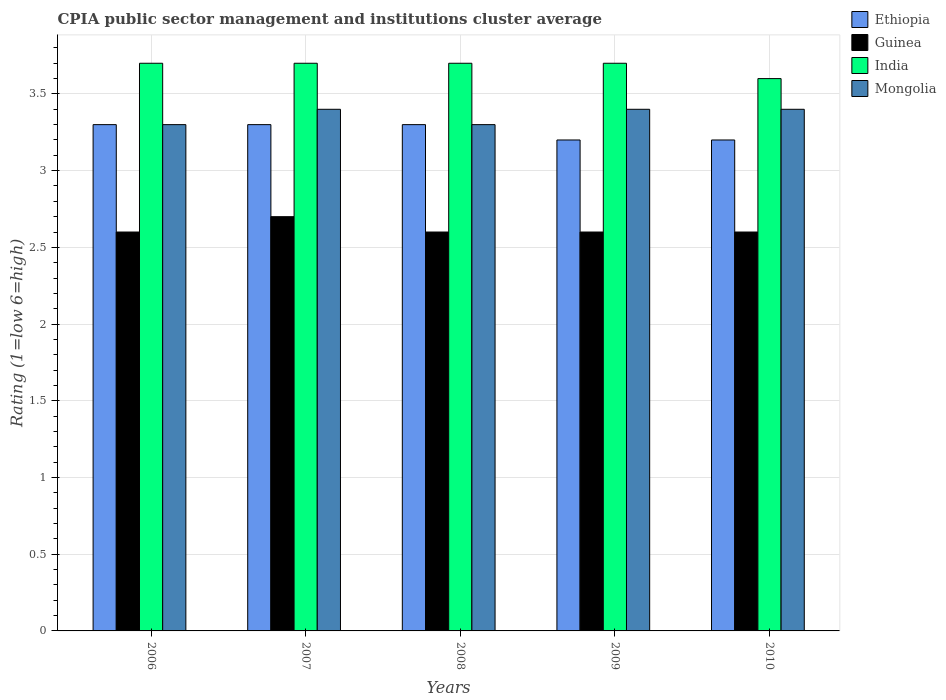How many different coloured bars are there?
Your response must be concise. 4. How many bars are there on the 5th tick from the left?
Your answer should be compact. 4. How many bars are there on the 2nd tick from the right?
Provide a succinct answer. 4. What is the label of the 4th group of bars from the left?
Your answer should be very brief. 2009. What is the CPIA rating in India in 2008?
Provide a succinct answer. 3.7. Across all years, what is the maximum CPIA rating in Ethiopia?
Ensure brevity in your answer.  3.3. Across all years, what is the minimum CPIA rating in Ethiopia?
Provide a short and direct response. 3.2. In which year was the CPIA rating in India maximum?
Offer a terse response. 2006. In which year was the CPIA rating in Guinea minimum?
Provide a short and direct response. 2006. What is the difference between the CPIA rating in Mongolia in 2006 and that in 2010?
Provide a short and direct response. -0.1. What is the difference between the CPIA rating in Guinea in 2010 and the CPIA rating in Mongolia in 2009?
Your answer should be compact. -0.8. What is the average CPIA rating in Ethiopia per year?
Your answer should be very brief. 3.26. In the year 2008, what is the difference between the CPIA rating in India and CPIA rating in Guinea?
Make the answer very short. 1.1. In how many years, is the CPIA rating in Guinea greater than 0.5?
Provide a short and direct response. 5. What is the ratio of the CPIA rating in Ethiopia in 2007 to that in 2008?
Provide a short and direct response. 1. Is the CPIA rating in India in 2007 less than that in 2008?
Keep it short and to the point. No. Is the difference between the CPIA rating in India in 2007 and 2009 greater than the difference between the CPIA rating in Guinea in 2007 and 2009?
Your answer should be compact. No. What is the difference between the highest and the lowest CPIA rating in Ethiopia?
Give a very brief answer. 0.1. Is the sum of the CPIA rating in India in 2006 and 2007 greater than the maximum CPIA rating in Ethiopia across all years?
Provide a succinct answer. Yes. What does the 1st bar from the left in 2010 represents?
Provide a short and direct response. Ethiopia. What does the 1st bar from the right in 2006 represents?
Offer a terse response. Mongolia. Are all the bars in the graph horizontal?
Provide a succinct answer. No. What is the difference between two consecutive major ticks on the Y-axis?
Your answer should be compact. 0.5. Are the values on the major ticks of Y-axis written in scientific E-notation?
Your response must be concise. No. Does the graph contain grids?
Offer a very short reply. Yes. Where does the legend appear in the graph?
Make the answer very short. Top right. How many legend labels are there?
Your answer should be compact. 4. How are the legend labels stacked?
Provide a short and direct response. Vertical. What is the title of the graph?
Ensure brevity in your answer.  CPIA public sector management and institutions cluster average. Does "Euro area" appear as one of the legend labels in the graph?
Provide a succinct answer. No. What is the Rating (1=low 6=high) of Ethiopia in 2006?
Provide a short and direct response. 3.3. What is the Rating (1=low 6=high) of Guinea in 2006?
Make the answer very short. 2.6. What is the Rating (1=low 6=high) of India in 2006?
Your response must be concise. 3.7. What is the Rating (1=low 6=high) in Mongolia in 2006?
Your answer should be very brief. 3.3. What is the Rating (1=low 6=high) in Ethiopia in 2007?
Provide a succinct answer. 3.3. What is the Rating (1=low 6=high) of India in 2008?
Your response must be concise. 3.7. What is the Rating (1=low 6=high) of Guinea in 2009?
Provide a succinct answer. 2.6. What is the Rating (1=low 6=high) in India in 2009?
Your answer should be very brief. 3.7. What is the Rating (1=low 6=high) in Mongolia in 2009?
Your answer should be compact. 3.4. What is the Rating (1=low 6=high) in Guinea in 2010?
Your response must be concise. 2.6. What is the Rating (1=low 6=high) of India in 2010?
Offer a very short reply. 3.6. Across all years, what is the maximum Rating (1=low 6=high) of Ethiopia?
Make the answer very short. 3.3. Across all years, what is the maximum Rating (1=low 6=high) in Guinea?
Ensure brevity in your answer.  2.7. Across all years, what is the minimum Rating (1=low 6=high) in India?
Give a very brief answer. 3.6. Across all years, what is the minimum Rating (1=low 6=high) in Mongolia?
Offer a very short reply. 3.3. What is the total Rating (1=low 6=high) in Ethiopia in the graph?
Offer a very short reply. 16.3. What is the total Rating (1=low 6=high) of Guinea in the graph?
Offer a terse response. 13.1. What is the total Rating (1=low 6=high) of Mongolia in the graph?
Your answer should be compact. 16.8. What is the difference between the Rating (1=low 6=high) of Mongolia in 2006 and that in 2007?
Provide a succinct answer. -0.1. What is the difference between the Rating (1=low 6=high) in Guinea in 2006 and that in 2008?
Keep it short and to the point. 0. What is the difference between the Rating (1=low 6=high) in Ethiopia in 2006 and that in 2009?
Your response must be concise. 0.1. What is the difference between the Rating (1=low 6=high) in India in 2006 and that in 2009?
Your response must be concise. 0. What is the difference between the Rating (1=low 6=high) in Ethiopia in 2006 and that in 2010?
Give a very brief answer. 0.1. What is the difference between the Rating (1=low 6=high) in India in 2006 and that in 2010?
Offer a very short reply. 0.1. What is the difference between the Rating (1=low 6=high) of Guinea in 2007 and that in 2008?
Your answer should be compact. 0.1. What is the difference between the Rating (1=low 6=high) in Ethiopia in 2007 and that in 2009?
Keep it short and to the point. 0.1. What is the difference between the Rating (1=low 6=high) of Mongolia in 2007 and that in 2009?
Make the answer very short. 0. What is the difference between the Rating (1=low 6=high) in Ethiopia in 2007 and that in 2010?
Your answer should be very brief. 0.1. What is the difference between the Rating (1=low 6=high) in Guinea in 2007 and that in 2010?
Keep it short and to the point. 0.1. What is the difference between the Rating (1=low 6=high) in Guinea in 2008 and that in 2009?
Offer a terse response. 0. What is the difference between the Rating (1=low 6=high) of Mongolia in 2008 and that in 2009?
Offer a terse response. -0.1. What is the difference between the Rating (1=low 6=high) in Guinea in 2008 and that in 2010?
Make the answer very short. 0. What is the difference between the Rating (1=low 6=high) of Ethiopia in 2009 and that in 2010?
Your answer should be compact. 0. What is the difference between the Rating (1=low 6=high) in Guinea in 2009 and that in 2010?
Provide a short and direct response. 0. What is the difference between the Rating (1=low 6=high) in Ethiopia in 2006 and the Rating (1=low 6=high) in Guinea in 2007?
Provide a succinct answer. 0.6. What is the difference between the Rating (1=low 6=high) of Guinea in 2006 and the Rating (1=low 6=high) of India in 2007?
Your response must be concise. -1.1. What is the difference between the Rating (1=low 6=high) of Guinea in 2006 and the Rating (1=low 6=high) of Mongolia in 2007?
Make the answer very short. -0.8. What is the difference between the Rating (1=low 6=high) of India in 2006 and the Rating (1=low 6=high) of Mongolia in 2007?
Provide a short and direct response. 0.3. What is the difference between the Rating (1=low 6=high) of Ethiopia in 2006 and the Rating (1=low 6=high) of Guinea in 2008?
Provide a short and direct response. 0.7. What is the difference between the Rating (1=low 6=high) in Ethiopia in 2006 and the Rating (1=low 6=high) in Guinea in 2009?
Your answer should be very brief. 0.7. What is the difference between the Rating (1=low 6=high) of Ethiopia in 2006 and the Rating (1=low 6=high) of Mongolia in 2009?
Provide a succinct answer. -0.1. What is the difference between the Rating (1=low 6=high) in Guinea in 2006 and the Rating (1=low 6=high) in India in 2009?
Keep it short and to the point. -1.1. What is the difference between the Rating (1=low 6=high) of India in 2006 and the Rating (1=low 6=high) of Mongolia in 2009?
Make the answer very short. 0.3. What is the difference between the Rating (1=low 6=high) of Ethiopia in 2006 and the Rating (1=low 6=high) of Guinea in 2010?
Make the answer very short. 0.7. What is the difference between the Rating (1=low 6=high) of Guinea in 2006 and the Rating (1=low 6=high) of India in 2010?
Give a very brief answer. -1. What is the difference between the Rating (1=low 6=high) in Guinea in 2006 and the Rating (1=low 6=high) in Mongolia in 2010?
Offer a terse response. -0.8. What is the difference between the Rating (1=low 6=high) of India in 2006 and the Rating (1=low 6=high) of Mongolia in 2010?
Your answer should be compact. 0.3. What is the difference between the Rating (1=low 6=high) in Ethiopia in 2007 and the Rating (1=low 6=high) in India in 2008?
Give a very brief answer. -0.4. What is the difference between the Rating (1=low 6=high) of Guinea in 2007 and the Rating (1=low 6=high) of India in 2008?
Provide a short and direct response. -1. What is the difference between the Rating (1=low 6=high) of Ethiopia in 2007 and the Rating (1=low 6=high) of India in 2009?
Provide a short and direct response. -0.4. What is the difference between the Rating (1=low 6=high) of Ethiopia in 2007 and the Rating (1=low 6=high) of Mongolia in 2009?
Keep it short and to the point. -0.1. What is the difference between the Rating (1=low 6=high) in Guinea in 2007 and the Rating (1=low 6=high) in India in 2009?
Provide a succinct answer. -1. What is the difference between the Rating (1=low 6=high) of India in 2007 and the Rating (1=low 6=high) of Mongolia in 2009?
Provide a short and direct response. 0.3. What is the difference between the Rating (1=low 6=high) in Ethiopia in 2007 and the Rating (1=low 6=high) in Mongolia in 2010?
Offer a very short reply. -0.1. What is the difference between the Rating (1=low 6=high) in Guinea in 2007 and the Rating (1=low 6=high) in India in 2010?
Offer a very short reply. -0.9. What is the difference between the Rating (1=low 6=high) of Guinea in 2007 and the Rating (1=low 6=high) of Mongolia in 2010?
Your response must be concise. -0.7. What is the difference between the Rating (1=low 6=high) in India in 2007 and the Rating (1=low 6=high) in Mongolia in 2010?
Your response must be concise. 0.3. What is the difference between the Rating (1=low 6=high) of Ethiopia in 2008 and the Rating (1=low 6=high) of Guinea in 2009?
Provide a succinct answer. 0.7. What is the difference between the Rating (1=low 6=high) in Ethiopia in 2008 and the Rating (1=low 6=high) in Mongolia in 2009?
Provide a short and direct response. -0.1. What is the difference between the Rating (1=low 6=high) in Guinea in 2008 and the Rating (1=low 6=high) in Mongolia in 2009?
Keep it short and to the point. -0.8. What is the difference between the Rating (1=low 6=high) of Ethiopia in 2008 and the Rating (1=low 6=high) of Guinea in 2010?
Your response must be concise. 0.7. What is the difference between the Rating (1=low 6=high) in Ethiopia in 2008 and the Rating (1=low 6=high) in India in 2010?
Ensure brevity in your answer.  -0.3. What is the difference between the Rating (1=low 6=high) in Ethiopia in 2009 and the Rating (1=low 6=high) in Guinea in 2010?
Ensure brevity in your answer.  0.6. What is the difference between the Rating (1=low 6=high) in Ethiopia in 2009 and the Rating (1=low 6=high) in India in 2010?
Your answer should be compact. -0.4. What is the difference between the Rating (1=low 6=high) of Ethiopia in 2009 and the Rating (1=low 6=high) of Mongolia in 2010?
Provide a short and direct response. -0.2. What is the difference between the Rating (1=low 6=high) of Guinea in 2009 and the Rating (1=low 6=high) of India in 2010?
Your answer should be compact. -1. What is the difference between the Rating (1=low 6=high) in Guinea in 2009 and the Rating (1=low 6=high) in Mongolia in 2010?
Make the answer very short. -0.8. What is the difference between the Rating (1=low 6=high) in India in 2009 and the Rating (1=low 6=high) in Mongolia in 2010?
Your answer should be compact. 0.3. What is the average Rating (1=low 6=high) in Ethiopia per year?
Give a very brief answer. 3.26. What is the average Rating (1=low 6=high) of Guinea per year?
Keep it short and to the point. 2.62. What is the average Rating (1=low 6=high) of India per year?
Give a very brief answer. 3.68. What is the average Rating (1=low 6=high) in Mongolia per year?
Provide a succinct answer. 3.36. In the year 2006, what is the difference between the Rating (1=low 6=high) of Ethiopia and Rating (1=low 6=high) of Guinea?
Your answer should be compact. 0.7. In the year 2006, what is the difference between the Rating (1=low 6=high) in Guinea and Rating (1=low 6=high) in India?
Give a very brief answer. -1.1. In the year 2006, what is the difference between the Rating (1=low 6=high) of Guinea and Rating (1=low 6=high) of Mongolia?
Offer a terse response. -0.7. In the year 2006, what is the difference between the Rating (1=low 6=high) of India and Rating (1=low 6=high) of Mongolia?
Keep it short and to the point. 0.4. In the year 2007, what is the difference between the Rating (1=low 6=high) in Ethiopia and Rating (1=low 6=high) in India?
Provide a succinct answer. -0.4. In the year 2007, what is the difference between the Rating (1=low 6=high) of Ethiopia and Rating (1=low 6=high) of Mongolia?
Your answer should be compact. -0.1. In the year 2007, what is the difference between the Rating (1=low 6=high) of Guinea and Rating (1=low 6=high) of Mongolia?
Give a very brief answer. -0.7. In the year 2007, what is the difference between the Rating (1=low 6=high) in India and Rating (1=low 6=high) in Mongolia?
Make the answer very short. 0.3. In the year 2008, what is the difference between the Rating (1=low 6=high) of Ethiopia and Rating (1=low 6=high) of Guinea?
Your answer should be compact. 0.7. In the year 2008, what is the difference between the Rating (1=low 6=high) of Ethiopia and Rating (1=low 6=high) of India?
Your answer should be compact. -0.4. In the year 2008, what is the difference between the Rating (1=low 6=high) in Ethiopia and Rating (1=low 6=high) in Mongolia?
Make the answer very short. 0. In the year 2009, what is the difference between the Rating (1=low 6=high) of Guinea and Rating (1=low 6=high) of India?
Provide a short and direct response. -1.1. In the year 2010, what is the difference between the Rating (1=low 6=high) of Ethiopia and Rating (1=low 6=high) of India?
Provide a succinct answer. -0.4. In the year 2010, what is the difference between the Rating (1=low 6=high) in India and Rating (1=low 6=high) in Mongolia?
Make the answer very short. 0.2. What is the ratio of the Rating (1=low 6=high) in Guinea in 2006 to that in 2007?
Keep it short and to the point. 0.96. What is the ratio of the Rating (1=low 6=high) of India in 2006 to that in 2007?
Your response must be concise. 1. What is the ratio of the Rating (1=low 6=high) of Mongolia in 2006 to that in 2007?
Your response must be concise. 0.97. What is the ratio of the Rating (1=low 6=high) in Guinea in 2006 to that in 2008?
Give a very brief answer. 1. What is the ratio of the Rating (1=low 6=high) in India in 2006 to that in 2008?
Provide a succinct answer. 1. What is the ratio of the Rating (1=low 6=high) of Mongolia in 2006 to that in 2008?
Your answer should be very brief. 1. What is the ratio of the Rating (1=low 6=high) of Ethiopia in 2006 to that in 2009?
Make the answer very short. 1.03. What is the ratio of the Rating (1=low 6=high) in Guinea in 2006 to that in 2009?
Provide a short and direct response. 1. What is the ratio of the Rating (1=low 6=high) of India in 2006 to that in 2009?
Keep it short and to the point. 1. What is the ratio of the Rating (1=low 6=high) of Mongolia in 2006 to that in 2009?
Keep it short and to the point. 0.97. What is the ratio of the Rating (1=low 6=high) of Ethiopia in 2006 to that in 2010?
Your response must be concise. 1.03. What is the ratio of the Rating (1=low 6=high) of India in 2006 to that in 2010?
Your answer should be very brief. 1.03. What is the ratio of the Rating (1=low 6=high) in Mongolia in 2006 to that in 2010?
Provide a succinct answer. 0.97. What is the ratio of the Rating (1=low 6=high) of Guinea in 2007 to that in 2008?
Give a very brief answer. 1.04. What is the ratio of the Rating (1=low 6=high) of India in 2007 to that in 2008?
Give a very brief answer. 1. What is the ratio of the Rating (1=low 6=high) of Mongolia in 2007 to that in 2008?
Offer a very short reply. 1.03. What is the ratio of the Rating (1=low 6=high) of Ethiopia in 2007 to that in 2009?
Offer a very short reply. 1.03. What is the ratio of the Rating (1=low 6=high) in India in 2007 to that in 2009?
Offer a terse response. 1. What is the ratio of the Rating (1=low 6=high) of Ethiopia in 2007 to that in 2010?
Provide a succinct answer. 1.03. What is the ratio of the Rating (1=low 6=high) in Guinea in 2007 to that in 2010?
Provide a succinct answer. 1.04. What is the ratio of the Rating (1=low 6=high) in India in 2007 to that in 2010?
Your answer should be compact. 1.03. What is the ratio of the Rating (1=low 6=high) in Mongolia in 2007 to that in 2010?
Ensure brevity in your answer.  1. What is the ratio of the Rating (1=low 6=high) in Ethiopia in 2008 to that in 2009?
Ensure brevity in your answer.  1.03. What is the ratio of the Rating (1=low 6=high) of Mongolia in 2008 to that in 2009?
Your answer should be very brief. 0.97. What is the ratio of the Rating (1=low 6=high) of Ethiopia in 2008 to that in 2010?
Your answer should be very brief. 1.03. What is the ratio of the Rating (1=low 6=high) of India in 2008 to that in 2010?
Your answer should be very brief. 1.03. What is the ratio of the Rating (1=low 6=high) of Mongolia in 2008 to that in 2010?
Your answer should be very brief. 0.97. What is the ratio of the Rating (1=low 6=high) of Guinea in 2009 to that in 2010?
Your answer should be compact. 1. What is the ratio of the Rating (1=low 6=high) of India in 2009 to that in 2010?
Offer a terse response. 1.03. What is the difference between the highest and the second highest Rating (1=low 6=high) of Guinea?
Your answer should be very brief. 0.1. What is the difference between the highest and the second highest Rating (1=low 6=high) of Mongolia?
Ensure brevity in your answer.  0. What is the difference between the highest and the lowest Rating (1=low 6=high) in India?
Offer a terse response. 0.1. 